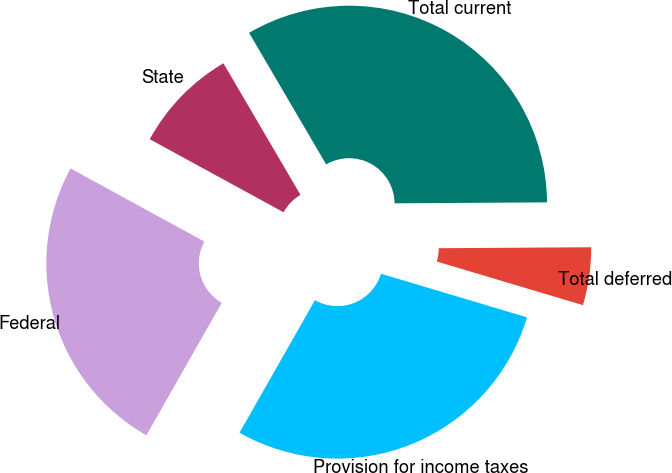Convert chart. <chart><loc_0><loc_0><loc_500><loc_500><pie_chart><fcel>Federal<fcel>State<fcel>Total current<fcel>Total deferred<fcel>Provision for income taxes<nl><fcel>24.72%<fcel>8.61%<fcel>33.33%<fcel>4.72%<fcel>28.61%<nl></chart> 